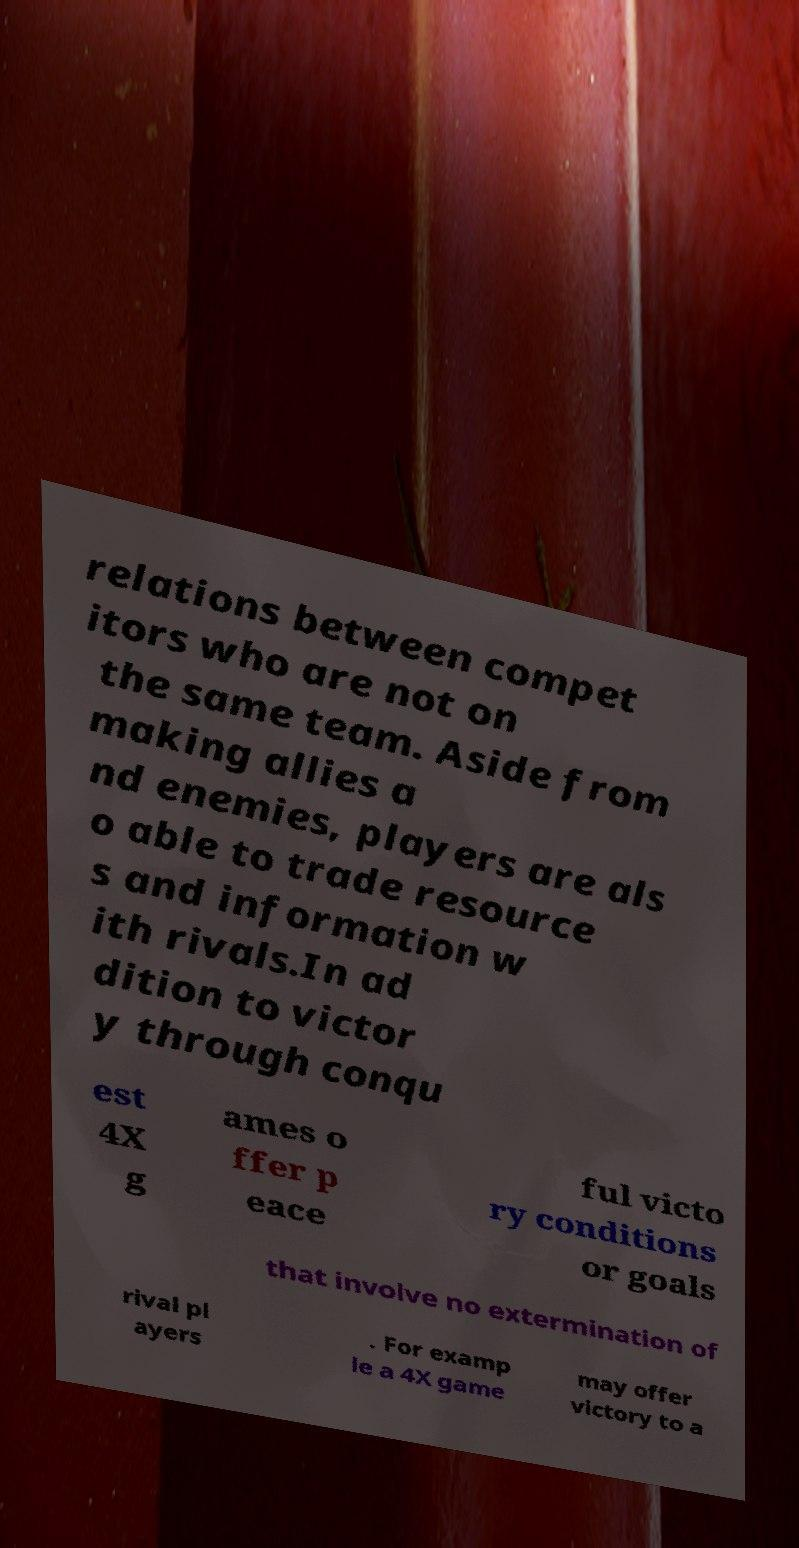For documentation purposes, I need the text within this image transcribed. Could you provide that? relations between compet itors who are not on the same team. Aside from making allies a nd enemies, players are als o able to trade resource s and information w ith rivals.In ad dition to victor y through conqu est 4X g ames o ffer p eace ful victo ry conditions or goals that involve no extermination of rival pl ayers . For examp le a 4X game may offer victory to a 